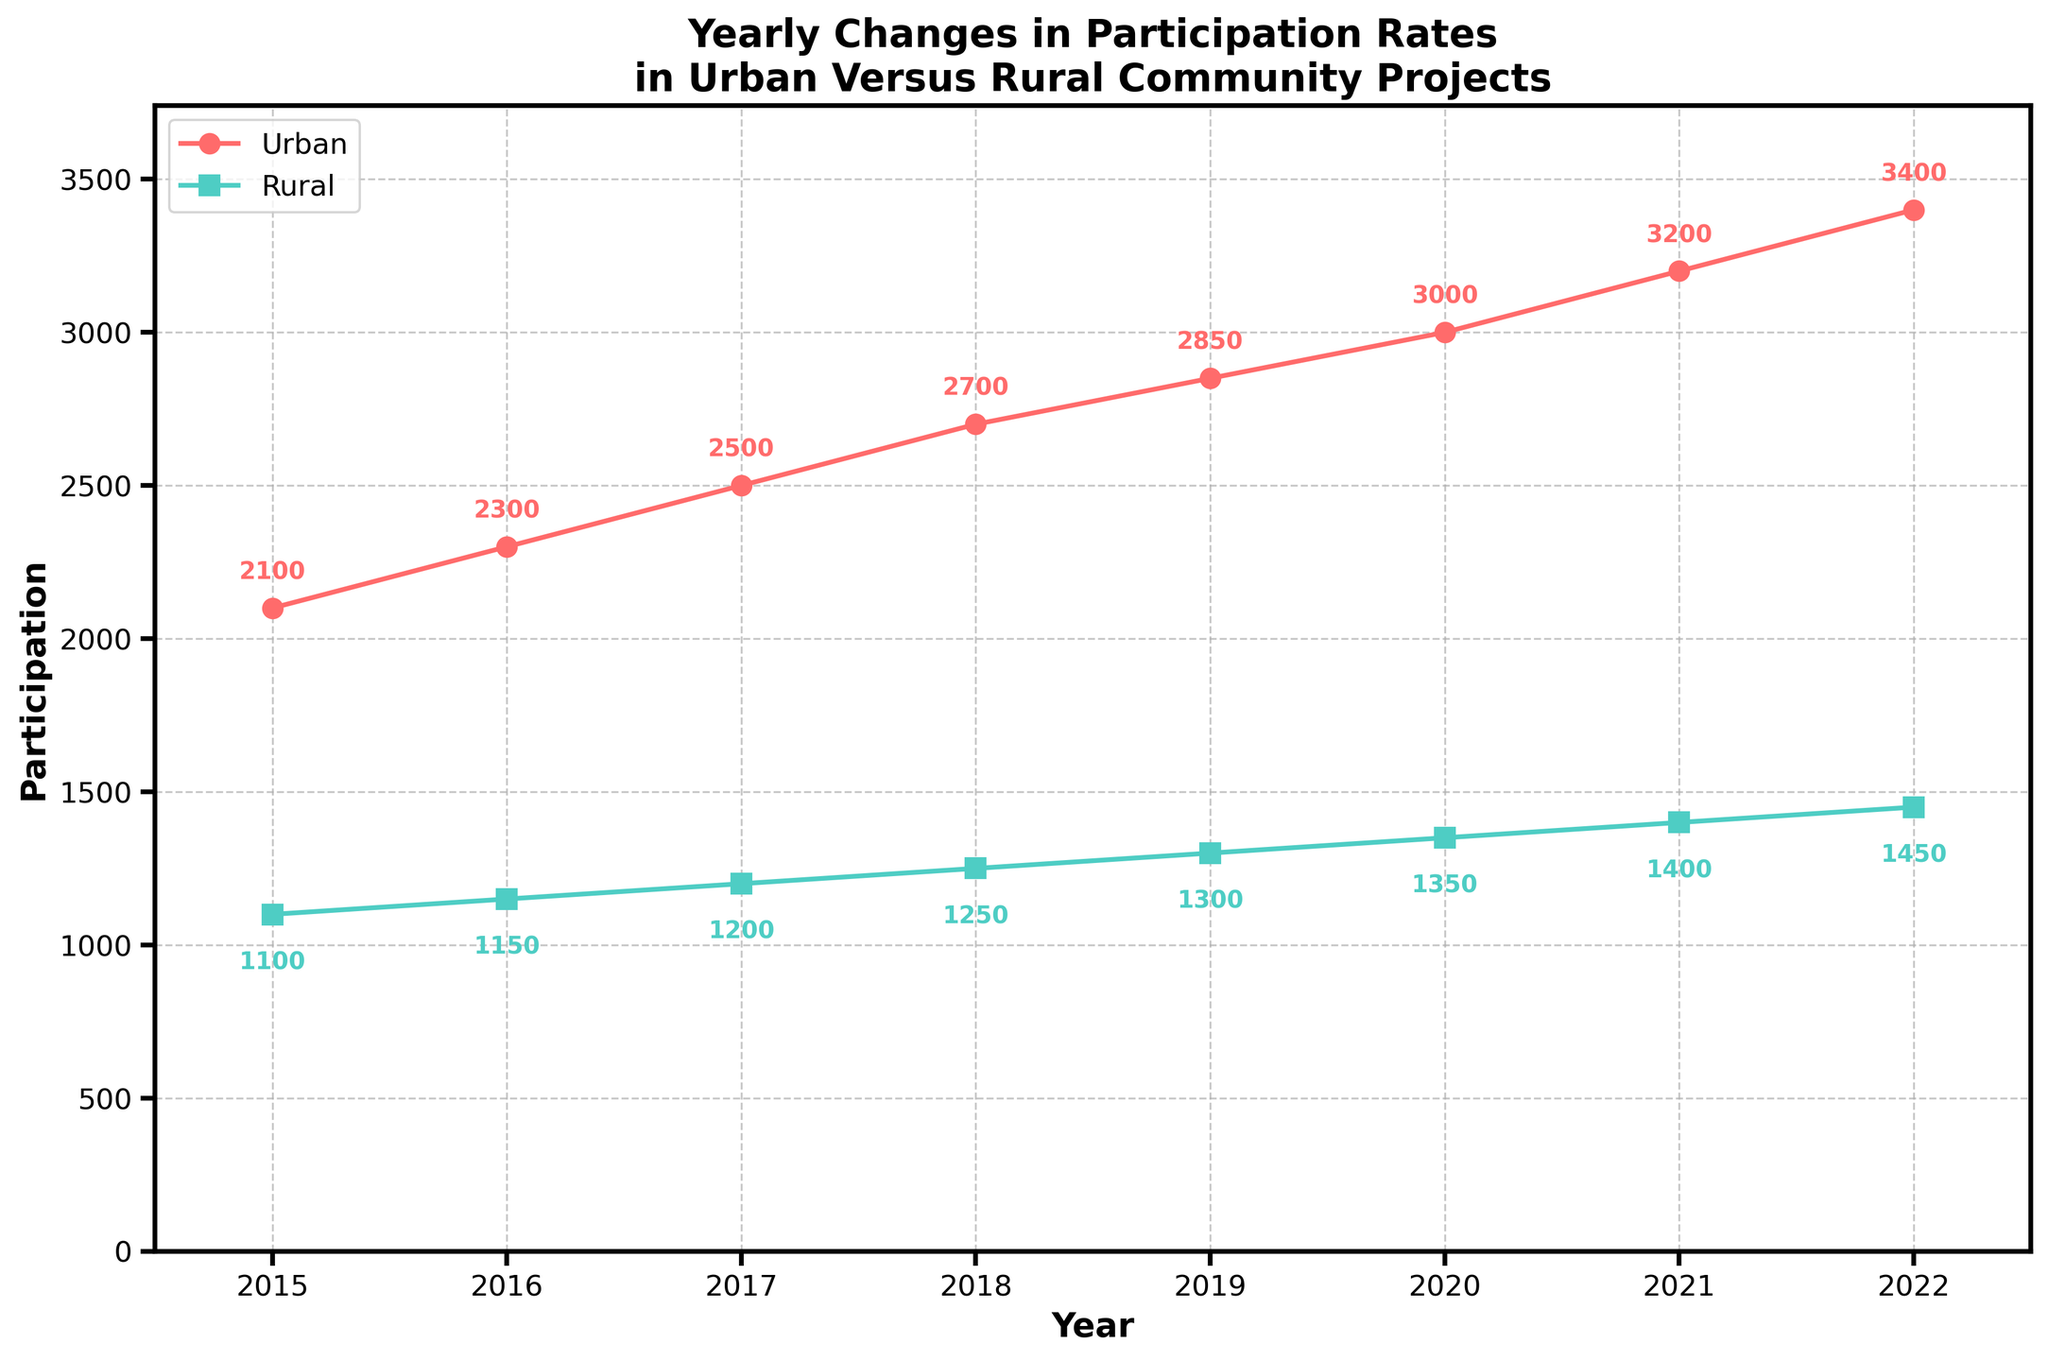What is the title of the plot? The title is located at the top center of the plot, displaying the subject of the visualization. The title is "Yearly Changes in Participation Rates in Urban Versus Rural Community Projects".
Answer: Yearly Changes in Participation Rates in Urban Versus Rural Community Projects How many years of data are shown in the plot? By counting the years marked on the x-axis, we see the data spans from 2015 to 2022, inclusive. This gives us 8 years of data.
Answer: 8 Which year has the highest urban participation rate? By looking at the data points for urban participation in each year, the highest point is in 2022, which corresponds to urban participation of 3400 people.
Answer: 2022 What is the increase in rural participation from 2015 to 2022? By calculating the difference between the rural participation in 2022 (1450) and that in 2015 (1100), we find the increase is 350.
Answer: 350 How does the trend of urban participation compare to rural participation over the years? Observing the plot lines, both urban and rural participation show a continuous upward trend from 2015 to 2022, but urban participation increases at a faster rate than rural participation.
Answer: Urban participation increases faster than rural participation In which year did urban participation increase the most compared to the previous year, and by how much? By comparing the differences in urban participation between consecutive years, the largest increase is from 2015 to 2016, where it increased by 200 (from 2100 to 2300).
Answer: 2016, 200 How much did rural participation increase from 2018 to 2019? By subtracting the rural participation in 2018 (1250) from that in 2019 (1300), the increase is 50.
Answer: 50 What are the percentages used to indicate the yearly changes in urban and rural participation rates and where are they displayed in the plot? The yearly percentage changes are indicated next to their respective data points on the graph with text annotations. These percentages describe the extent of participation change year over year. For example, urban participation increased by 9.5% from 2015 to 2016 and rural by 4.5% in the same period.
Answer: Next to the data points Compare the annual average increase in urban versus rural participation over the given years. Which one is greater? Calculate the differences in participation between each year and then average them out for urban and rural. Urban yearly increases: (200 + 200 + 200 + 150 + 150 + 200 + 200)/7 ≈ 185.7, Rural yearly increases: (50 + 50 + 50 + 50 + 50 + 50 + 50)/7 ≈ 50. Urban has a higher average annual increase.
Answer: Urban Which year showed the smallest increase in rural participation compared to the previous year? By comparing the rural participation increases year-over-year, the smallest increase is from 2021 (1400) to 2022 (1450), an increase of 50.
Answer: All years show the same increase 